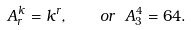<formula> <loc_0><loc_0><loc_500><loc_500>A ^ { k } _ { r } = k ^ { r } , \quad o r \ A ^ { 4 } _ { 3 } = 6 4 .</formula> 